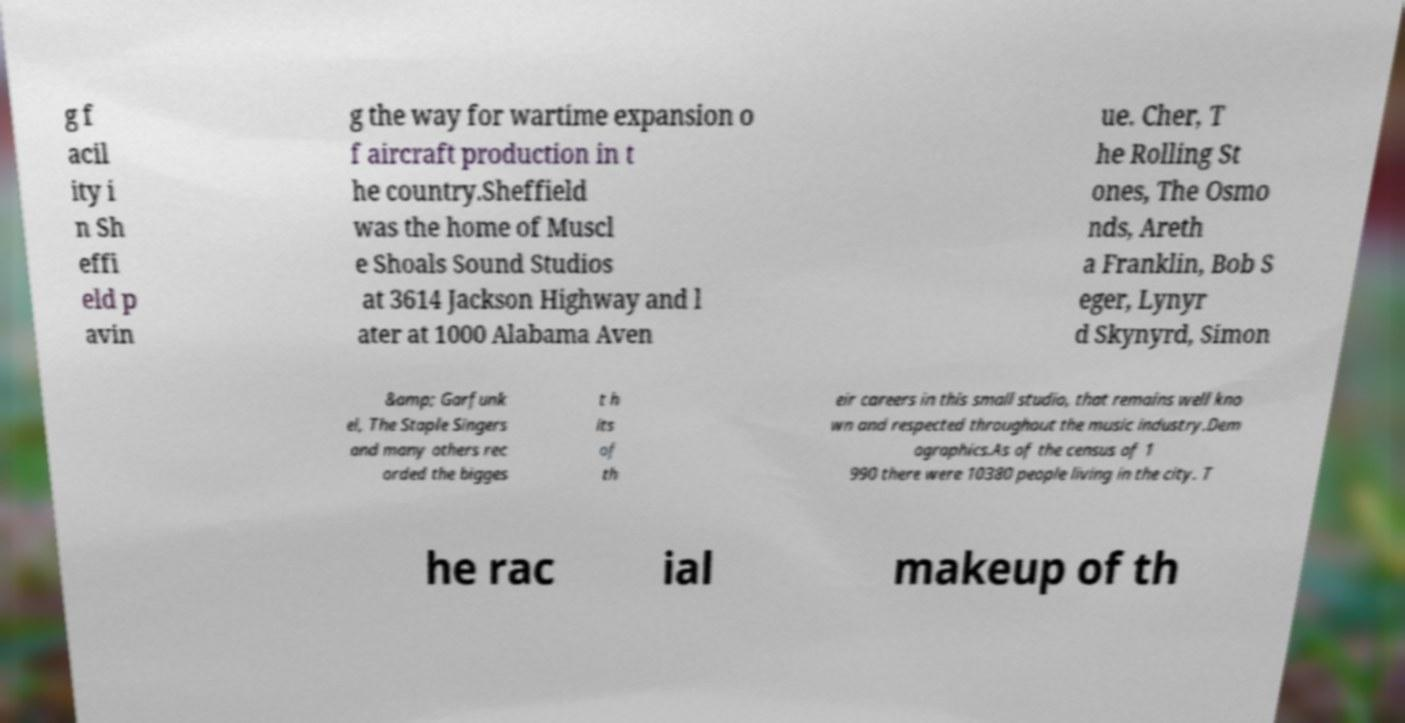What messages or text are displayed in this image? I need them in a readable, typed format. g f acil ity i n Sh effi eld p avin g the way for wartime expansion o f aircraft production in t he country.Sheffield was the home of Muscl e Shoals Sound Studios at 3614 Jackson Highway and l ater at 1000 Alabama Aven ue. Cher, T he Rolling St ones, The Osmo nds, Areth a Franklin, Bob S eger, Lynyr d Skynyrd, Simon &amp; Garfunk el, The Staple Singers and many others rec orded the bigges t h its of th eir careers in this small studio, that remains well kno wn and respected throughout the music industry.Dem ographics.As of the census of 1 990 there were 10380 people living in the city. T he rac ial makeup of th 